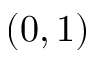<formula> <loc_0><loc_0><loc_500><loc_500>( 0 , 1 )</formula> 